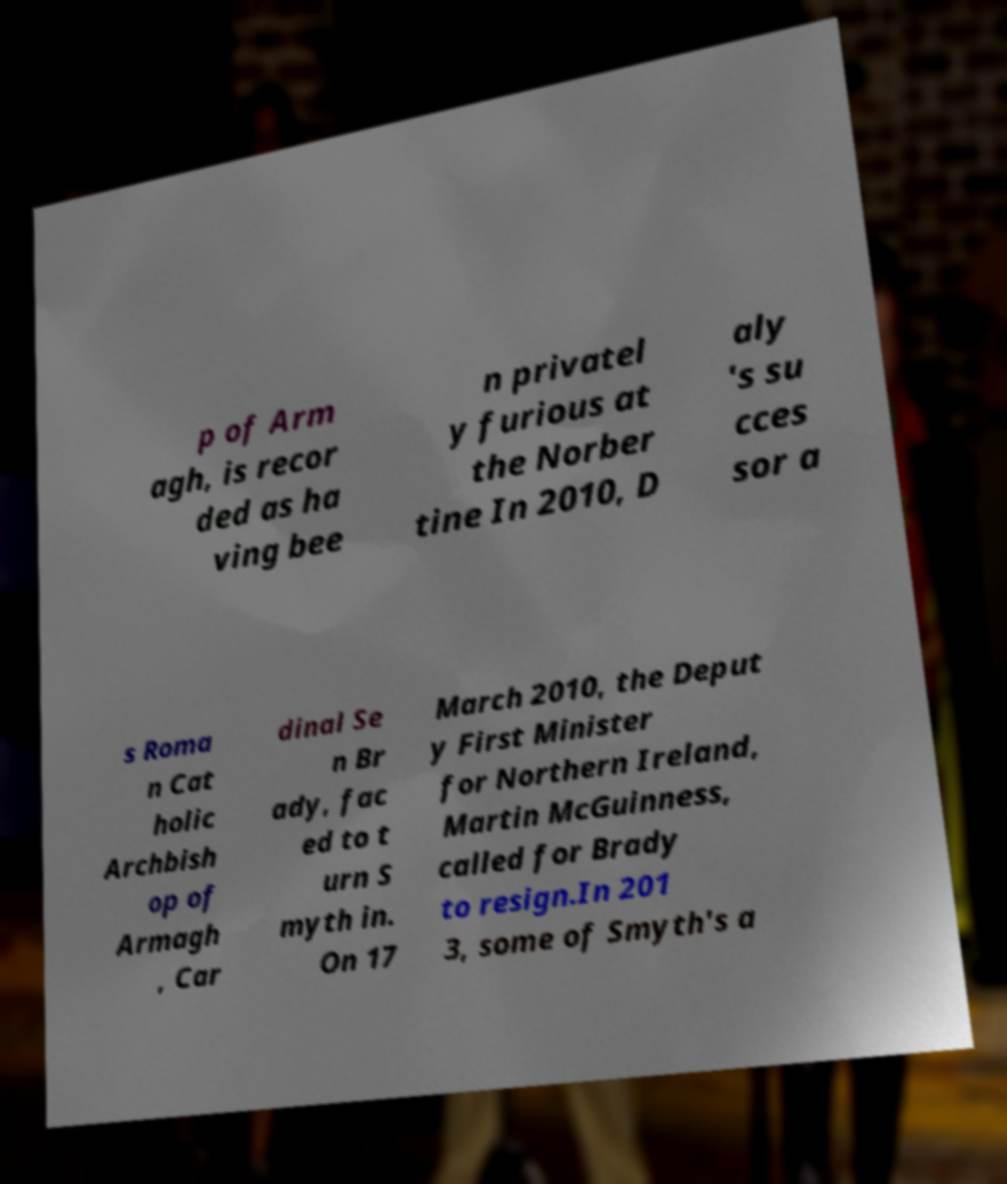Can you accurately transcribe the text from the provided image for me? p of Arm agh, is recor ded as ha ving bee n privatel y furious at the Norber tine In 2010, D aly 's su cces sor a s Roma n Cat holic Archbish op of Armagh , Car dinal Se n Br ady, fac ed to t urn S myth in. On 17 March 2010, the Deput y First Minister for Northern Ireland, Martin McGuinness, called for Brady to resign.In 201 3, some of Smyth's a 